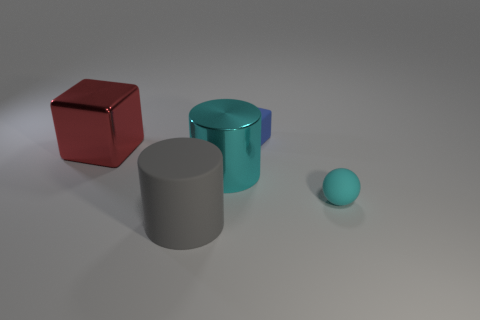Add 5 metal cubes. How many objects exist? 10 Subtract all balls. How many objects are left? 4 Subtract all blue blocks. How many blocks are left? 1 Subtract all blue cylinders. How many brown spheres are left? 0 Subtract all purple matte cylinders. Subtract all big gray cylinders. How many objects are left? 4 Add 2 small matte cubes. How many small matte cubes are left? 3 Add 3 red cubes. How many red cubes exist? 4 Subtract 0 brown spheres. How many objects are left? 5 Subtract 1 cubes. How many cubes are left? 1 Subtract all purple spheres. Subtract all cyan cylinders. How many spheres are left? 1 